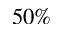Convert formula to latex. <formula><loc_0><loc_0><loc_500><loc_500>5 0 \%</formula> 